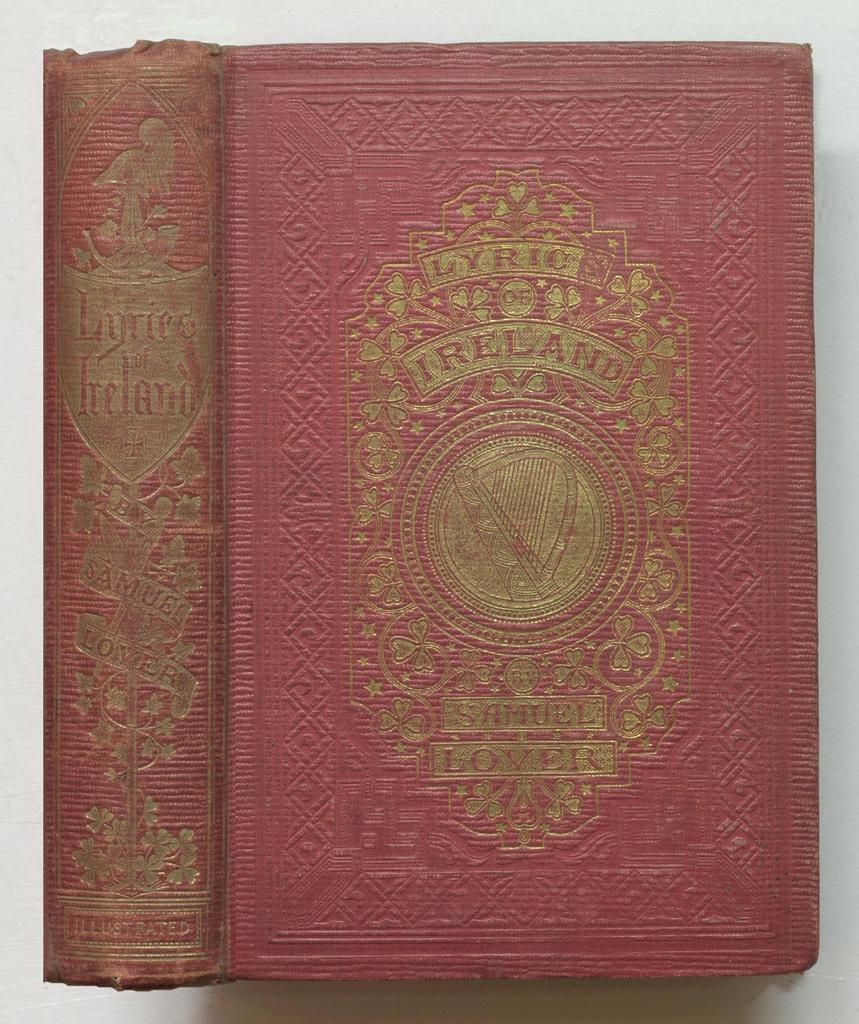What country is the book about?
Keep it short and to the point. Ireland. What is the title of this book?
Make the answer very short. Lyric ireland. 